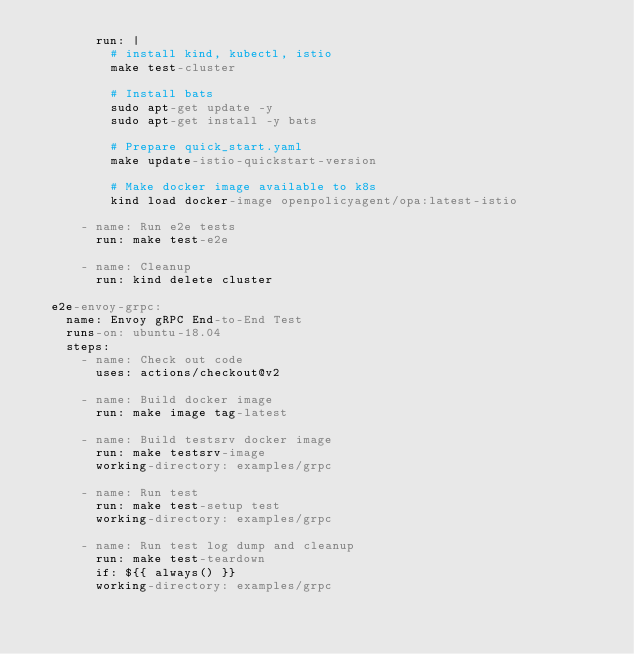Convert code to text. <code><loc_0><loc_0><loc_500><loc_500><_YAML_>        run: |
          # install kind, kubectl, istio
          make test-cluster

          # Install bats
          sudo apt-get update -y
          sudo apt-get install -y bats

          # Prepare quick_start.yaml
          make update-istio-quickstart-version

          # Make docker image available to k8s
          kind load docker-image openpolicyagent/opa:latest-istio

      - name: Run e2e tests
        run: make test-e2e

      - name: Cleanup
        run: kind delete cluster

  e2e-envoy-grpc:
    name: Envoy gRPC End-to-End Test
    runs-on: ubuntu-18.04
    steps:
      - name: Check out code
        uses: actions/checkout@v2

      - name: Build docker image
        run: make image tag-latest

      - name: Build testsrv docker image
        run: make testsrv-image
        working-directory: examples/grpc

      - name: Run test
        run: make test-setup test
        working-directory: examples/grpc

      - name: Run test log dump and cleanup
        run: make test-teardown
        if: ${{ always() }}
        working-directory: examples/grpc
</code> 